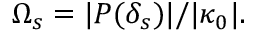<formula> <loc_0><loc_0><loc_500><loc_500>\Omega _ { s } = | P ( \delta _ { s } ) | / | \kappa _ { 0 } | .</formula> 